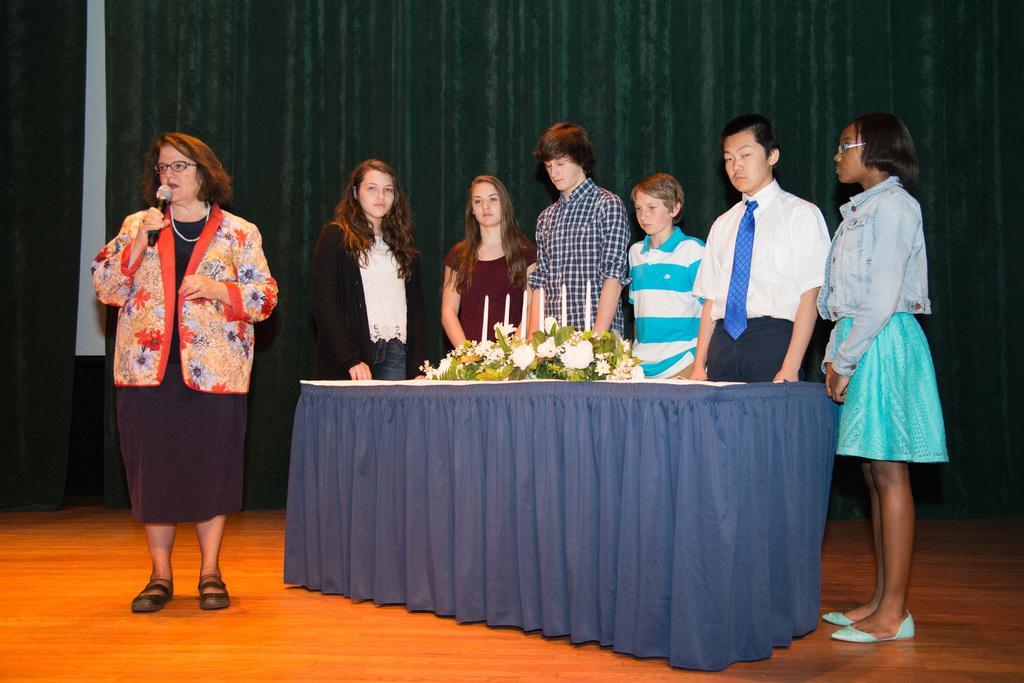How would you summarize this image in a sentence or two? In this image there are group of persons standing behind the blue color sheet at the left side of the image there is a woman standing and holding a microphone in her hand and on the top of the table there are candles and flower bouquet. 